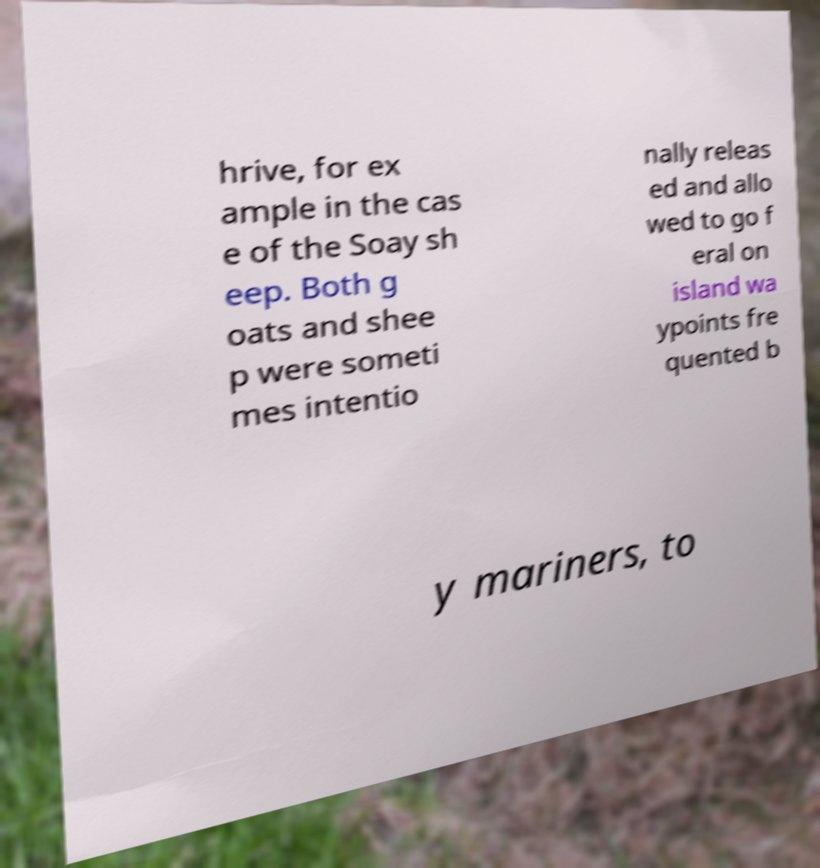Please read and relay the text visible in this image. What does it say? hrive, for ex ample in the cas e of the Soay sh eep. Both g oats and shee p were someti mes intentio nally releas ed and allo wed to go f eral on island wa ypoints fre quented b y mariners, to 